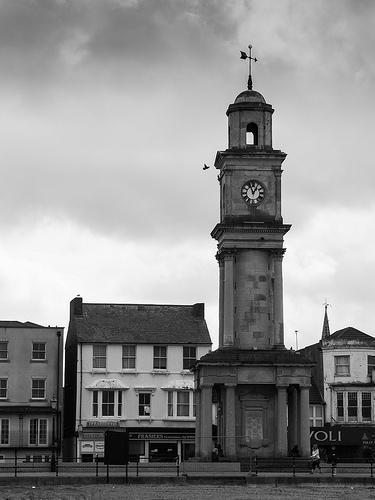How many people are in the picture?
Give a very brief answer. 1. 